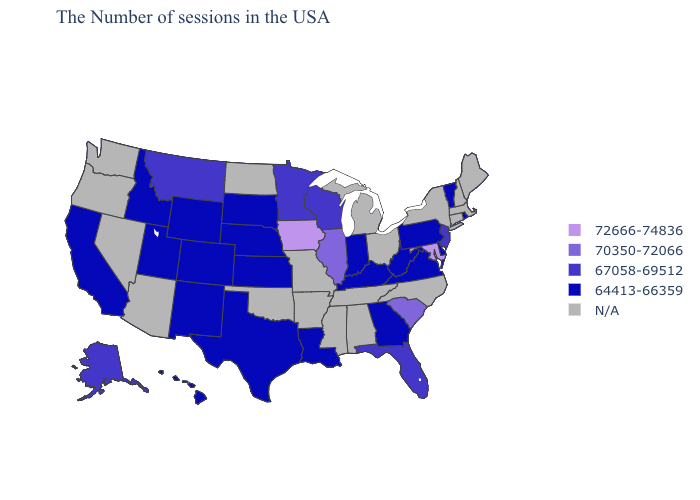What is the value of Alaska?
Write a very short answer. 67058-69512. Name the states that have a value in the range 64413-66359?
Short answer required. Rhode Island, Vermont, Delaware, Pennsylvania, Virginia, West Virginia, Georgia, Kentucky, Indiana, Louisiana, Kansas, Nebraska, Texas, South Dakota, Wyoming, Colorado, New Mexico, Utah, Idaho, California, Hawaii. Name the states that have a value in the range N/A?
Keep it brief. Maine, Massachusetts, New Hampshire, Connecticut, New York, North Carolina, Ohio, Michigan, Alabama, Tennessee, Mississippi, Missouri, Arkansas, Oklahoma, North Dakota, Arizona, Nevada, Washington, Oregon. Name the states that have a value in the range N/A?
Short answer required. Maine, Massachusetts, New Hampshire, Connecticut, New York, North Carolina, Ohio, Michigan, Alabama, Tennessee, Mississippi, Missouri, Arkansas, Oklahoma, North Dakota, Arizona, Nevada, Washington, Oregon. What is the lowest value in the USA?
Be succinct. 64413-66359. What is the value of Oregon?
Quick response, please. N/A. What is the value of Massachusetts?
Quick response, please. N/A. Does the first symbol in the legend represent the smallest category?
Concise answer only. No. Among the states that border Wisconsin , does Illinois have the lowest value?
Quick response, please. No. What is the value of Wyoming?
Quick response, please. 64413-66359. Name the states that have a value in the range 67058-69512?
Answer briefly. New Jersey, Florida, Wisconsin, Minnesota, Montana, Alaska. What is the lowest value in the USA?
Write a very short answer. 64413-66359. Does New Mexico have the highest value in the West?
Quick response, please. No. Name the states that have a value in the range 67058-69512?
Keep it brief. New Jersey, Florida, Wisconsin, Minnesota, Montana, Alaska. 